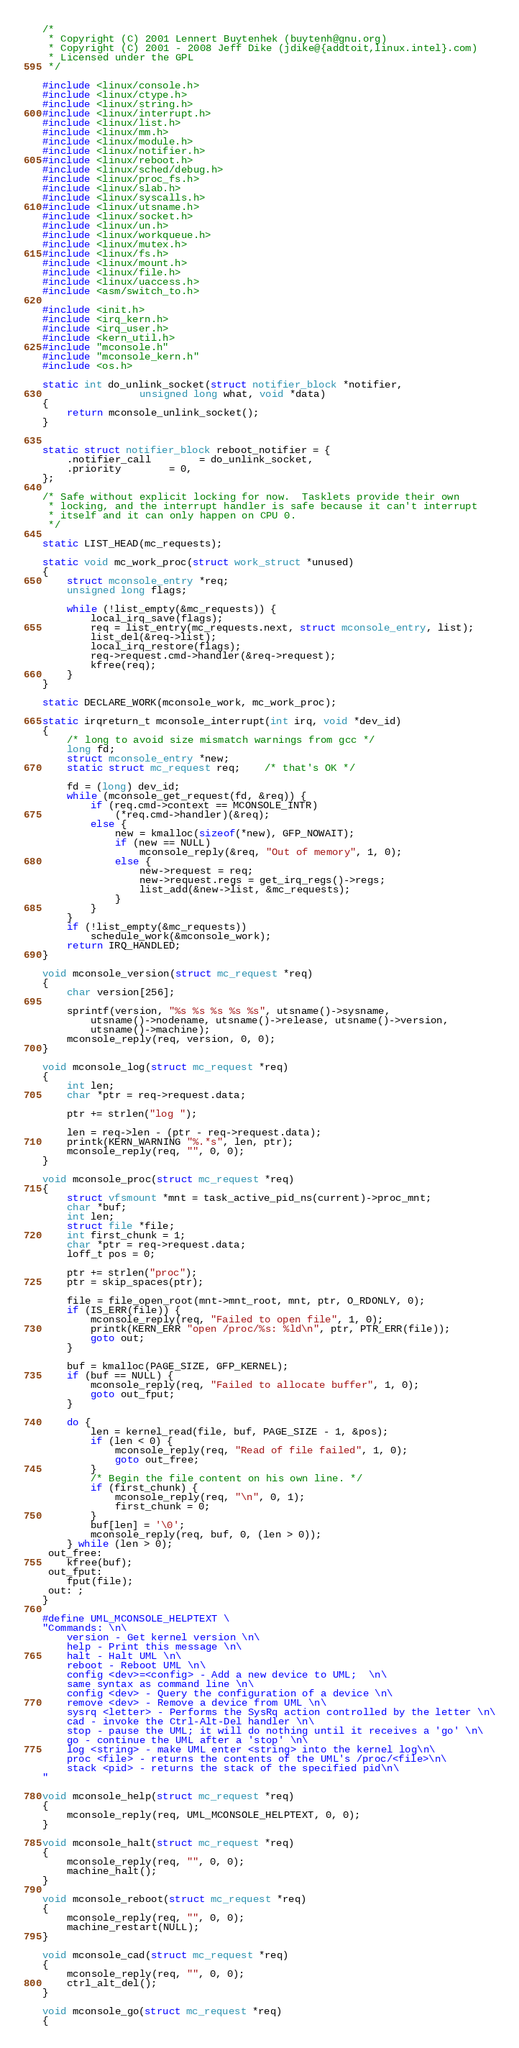Convert code to text. <code><loc_0><loc_0><loc_500><loc_500><_C_>/*
 * Copyright (C) 2001 Lennert Buytenhek (buytenh@gnu.org)
 * Copyright (C) 2001 - 2008 Jeff Dike (jdike@{addtoit,linux.intel}.com)
 * Licensed under the GPL
 */

#include <linux/console.h>
#include <linux/ctype.h>
#include <linux/string.h>
#include <linux/interrupt.h>
#include <linux/list.h>
#include <linux/mm.h>
#include <linux/module.h>
#include <linux/notifier.h>
#include <linux/reboot.h>
#include <linux/sched/debug.h>
#include <linux/proc_fs.h>
#include <linux/slab.h>
#include <linux/syscalls.h>
#include <linux/utsname.h>
#include <linux/socket.h>
#include <linux/un.h>
#include <linux/workqueue.h>
#include <linux/mutex.h>
#include <linux/fs.h>
#include <linux/mount.h>
#include <linux/file.h>
#include <linux/uaccess.h>
#include <asm/switch_to.h>

#include <init.h>
#include <irq_kern.h>
#include <irq_user.h>
#include <kern_util.h>
#include "mconsole.h"
#include "mconsole_kern.h"
#include <os.h>

static int do_unlink_socket(struct notifier_block *notifier,
			    unsigned long what, void *data)
{
	return mconsole_unlink_socket();
}


static struct notifier_block reboot_notifier = {
	.notifier_call		= do_unlink_socket,
	.priority		= 0,
};

/* Safe without explicit locking for now.  Tasklets provide their own
 * locking, and the interrupt handler is safe because it can't interrupt
 * itself and it can only happen on CPU 0.
 */

static LIST_HEAD(mc_requests);

static void mc_work_proc(struct work_struct *unused)
{
	struct mconsole_entry *req;
	unsigned long flags;

	while (!list_empty(&mc_requests)) {
		local_irq_save(flags);
		req = list_entry(mc_requests.next, struct mconsole_entry, list);
		list_del(&req->list);
		local_irq_restore(flags);
		req->request.cmd->handler(&req->request);
		kfree(req);
	}
}

static DECLARE_WORK(mconsole_work, mc_work_proc);

static irqreturn_t mconsole_interrupt(int irq, void *dev_id)
{
	/* long to avoid size mismatch warnings from gcc */
	long fd;
	struct mconsole_entry *new;
	static struct mc_request req;	/* that's OK */

	fd = (long) dev_id;
	while (mconsole_get_request(fd, &req)) {
		if (req.cmd->context == MCONSOLE_INTR)
			(*req.cmd->handler)(&req);
		else {
			new = kmalloc(sizeof(*new), GFP_NOWAIT);
			if (new == NULL)
				mconsole_reply(&req, "Out of memory", 1, 0);
			else {
				new->request = req;
				new->request.regs = get_irq_regs()->regs;
				list_add(&new->list, &mc_requests);
			}
		}
	}
	if (!list_empty(&mc_requests))
		schedule_work(&mconsole_work);
	return IRQ_HANDLED;
}

void mconsole_version(struct mc_request *req)
{
	char version[256];

	sprintf(version, "%s %s %s %s %s", utsname()->sysname,
		utsname()->nodename, utsname()->release, utsname()->version,
		utsname()->machine);
	mconsole_reply(req, version, 0, 0);
}

void mconsole_log(struct mc_request *req)
{
	int len;
	char *ptr = req->request.data;

	ptr += strlen("log ");

	len = req->len - (ptr - req->request.data);
	printk(KERN_WARNING "%.*s", len, ptr);
	mconsole_reply(req, "", 0, 0);
}

void mconsole_proc(struct mc_request *req)
{
	struct vfsmount *mnt = task_active_pid_ns(current)->proc_mnt;
	char *buf;
	int len;
	struct file *file;
	int first_chunk = 1;
	char *ptr = req->request.data;
	loff_t pos = 0;

	ptr += strlen("proc");
	ptr = skip_spaces(ptr);

	file = file_open_root(mnt->mnt_root, mnt, ptr, O_RDONLY, 0);
	if (IS_ERR(file)) {
		mconsole_reply(req, "Failed to open file", 1, 0);
		printk(KERN_ERR "open /proc/%s: %ld\n", ptr, PTR_ERR(file));
		goto out;
	}

	buf = kmalloc(PAGE_SIZE, GFP_KERNEL);
	if (buf == NULL) {
		mconsole_reply(req, "Failed to allocate buffer", 1, 0);
		goto out_fput;
	}

	do {
		len = kernel_read(file, buf, PAGE_SIZE - 1, &pos);
		if (len < 0) {
			mconsole_reply(req, "Read of file failed", 1, 0);
			goto out_free;
		}
		/* Begin the file content on his own line. */
		if (first_chunk) {
			mconsole_reply(req, "\n", 0, 1);
			first_chunk = 0;
		}
		buf[len] = '\0';
		mconsole_reply(req, buf, 0, (len > 0));
	} while (len > 0);
 out_free:
	kfree(buf);
 out_fput:
	fput(file);
 out: ;
}

#define UML_MCONSOLE_HELPTEXT \
"Commands: \n\
    version - Get kernel version \n\
    help - Print this message \n\
    halt - Halt UML \n\
    reboot - Reboot UML \n\
    config <dev>=<config> - Add a new device to UML;  \n\
	same syntax as command line \n\
    config <dev> - Query the configuration of a device \n\
    remove <dev> - Remove a device from UML \n\
    sysrq <letter> - Performs the SysRq action controlled by the letter \n\
    cad - invoke the Ctrl-Alt-Del handler \n\
    stop - pause the UML; it will do nothing until it receives a 'go' \n\
    go - continue the UML after a 'stop' \n\
    log <string> - make UML enter <string> into the kernel log\n\
    proc <file> - returns the contents of the UML's /proc/<file>\n\
    stack <pid> - returns the stack of the specified pid\n\
"

void mconsole_help(struct mc_request *req)
{
	mconsole_reply(req, UML_MCONSOLE_HELPTEXT, 0, 0);
}

void mconsole_halt(struct mc_request *req)
{
	mconsole_reply(req, "", 0, 0);
	machine_halt();
}

void mconsole_reboot(struct mc_request *req)
{
	mconsole_reply(req, "", 0, 0);
	machine_restart(NULL);
}

void mconsole_cad(struct mc_request *req)
{
	mconsole_reply(req, "", 0, 0);
	ctrl_alt_del();
}

void mconsole_go(struct mc_request *req)
{</code> 